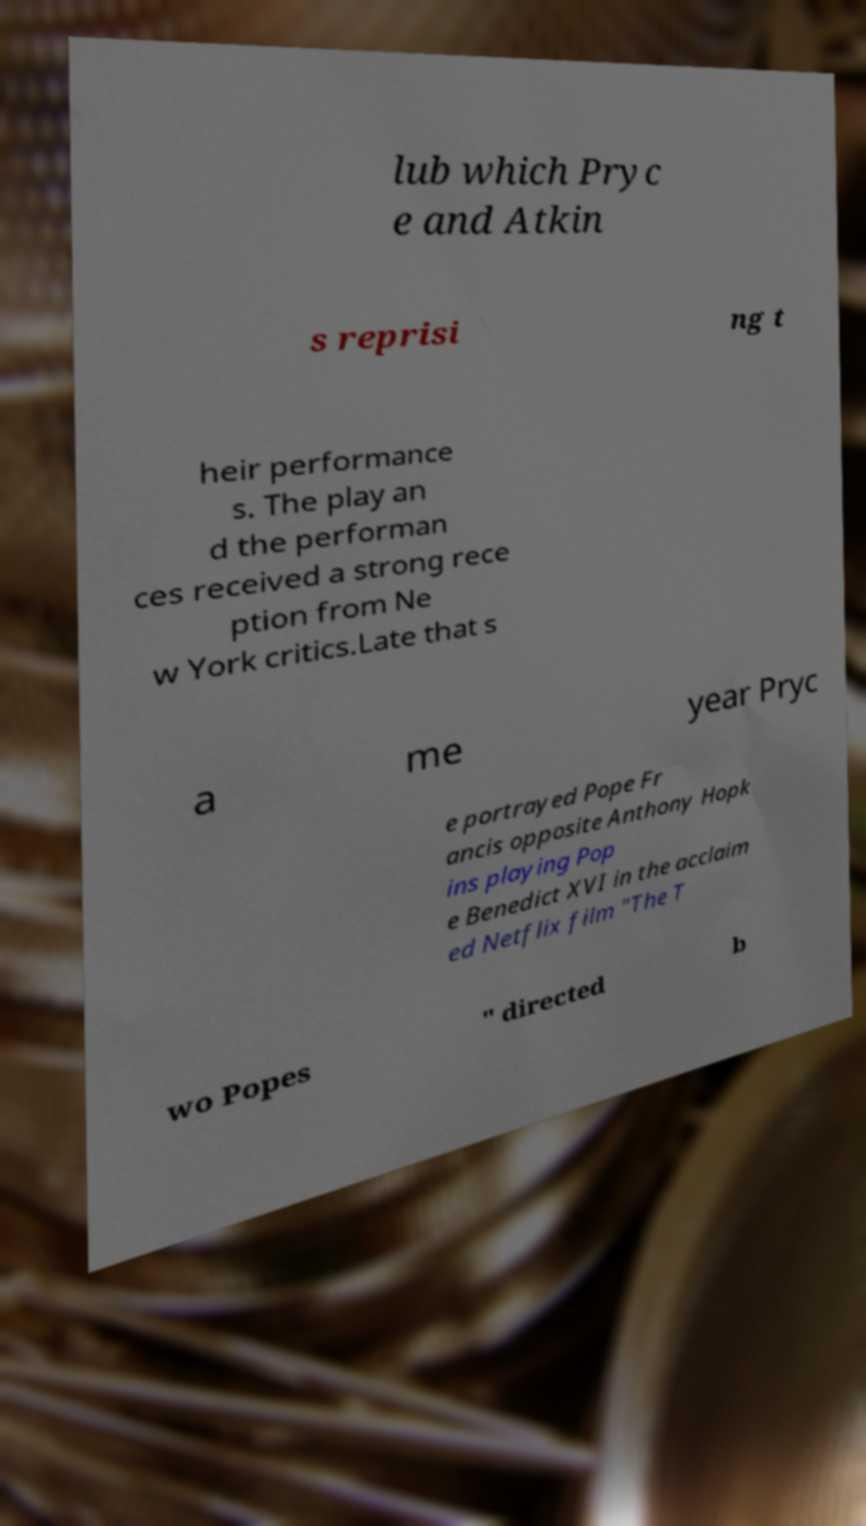Could you assist in decoding the text presented in this image and type it out clearly? lub which Pryc e and Atkin s reprisi ng t heir performance s. The play an d the performan ces received a strong rece ption from Ne w York critics.Late that s a me year Pryc e portrayed Pope Fr ancis opposite Anthony Hopk ins playing Pop e Benedict XVI in the acclaim ed Netflix film "The T wo Popes " directed b 